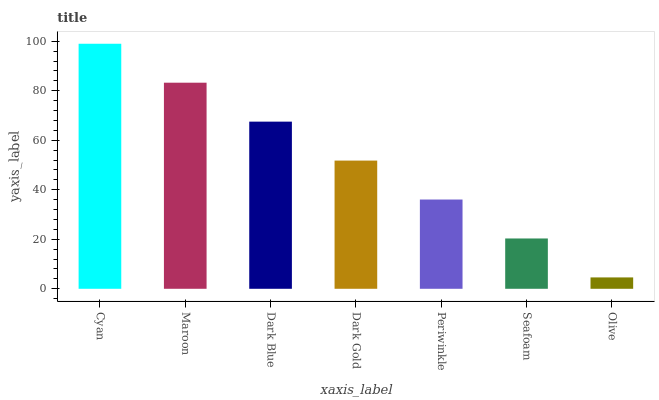Is Olive the minimum?
Answer yes or no. Yes. Is Cyan the maximum?
Answer yes or no. Yes. Is Maroon the minimum?
Answer yes or no. No. Is Maroon the maximum?
Answer yes or no. No. Is Cyan greater than Maroon?
Answer yes or no. Yes. Is Maroon less than Cyan?
Answer yes or no. Yes. Is Maroon greater than Cyan?
Answer yes or no. No. Is Cyan less than Maroon?
Answer yes or no. No. Is Dark Gold the high median?
Answer yes or no. Yes. Is Dark Gold the low median?
Answer yes or no. Yes. Is Maroon the high median?
Answer yes or no. No. Is Dark Blue the low median?
Answer yes or no. No. 